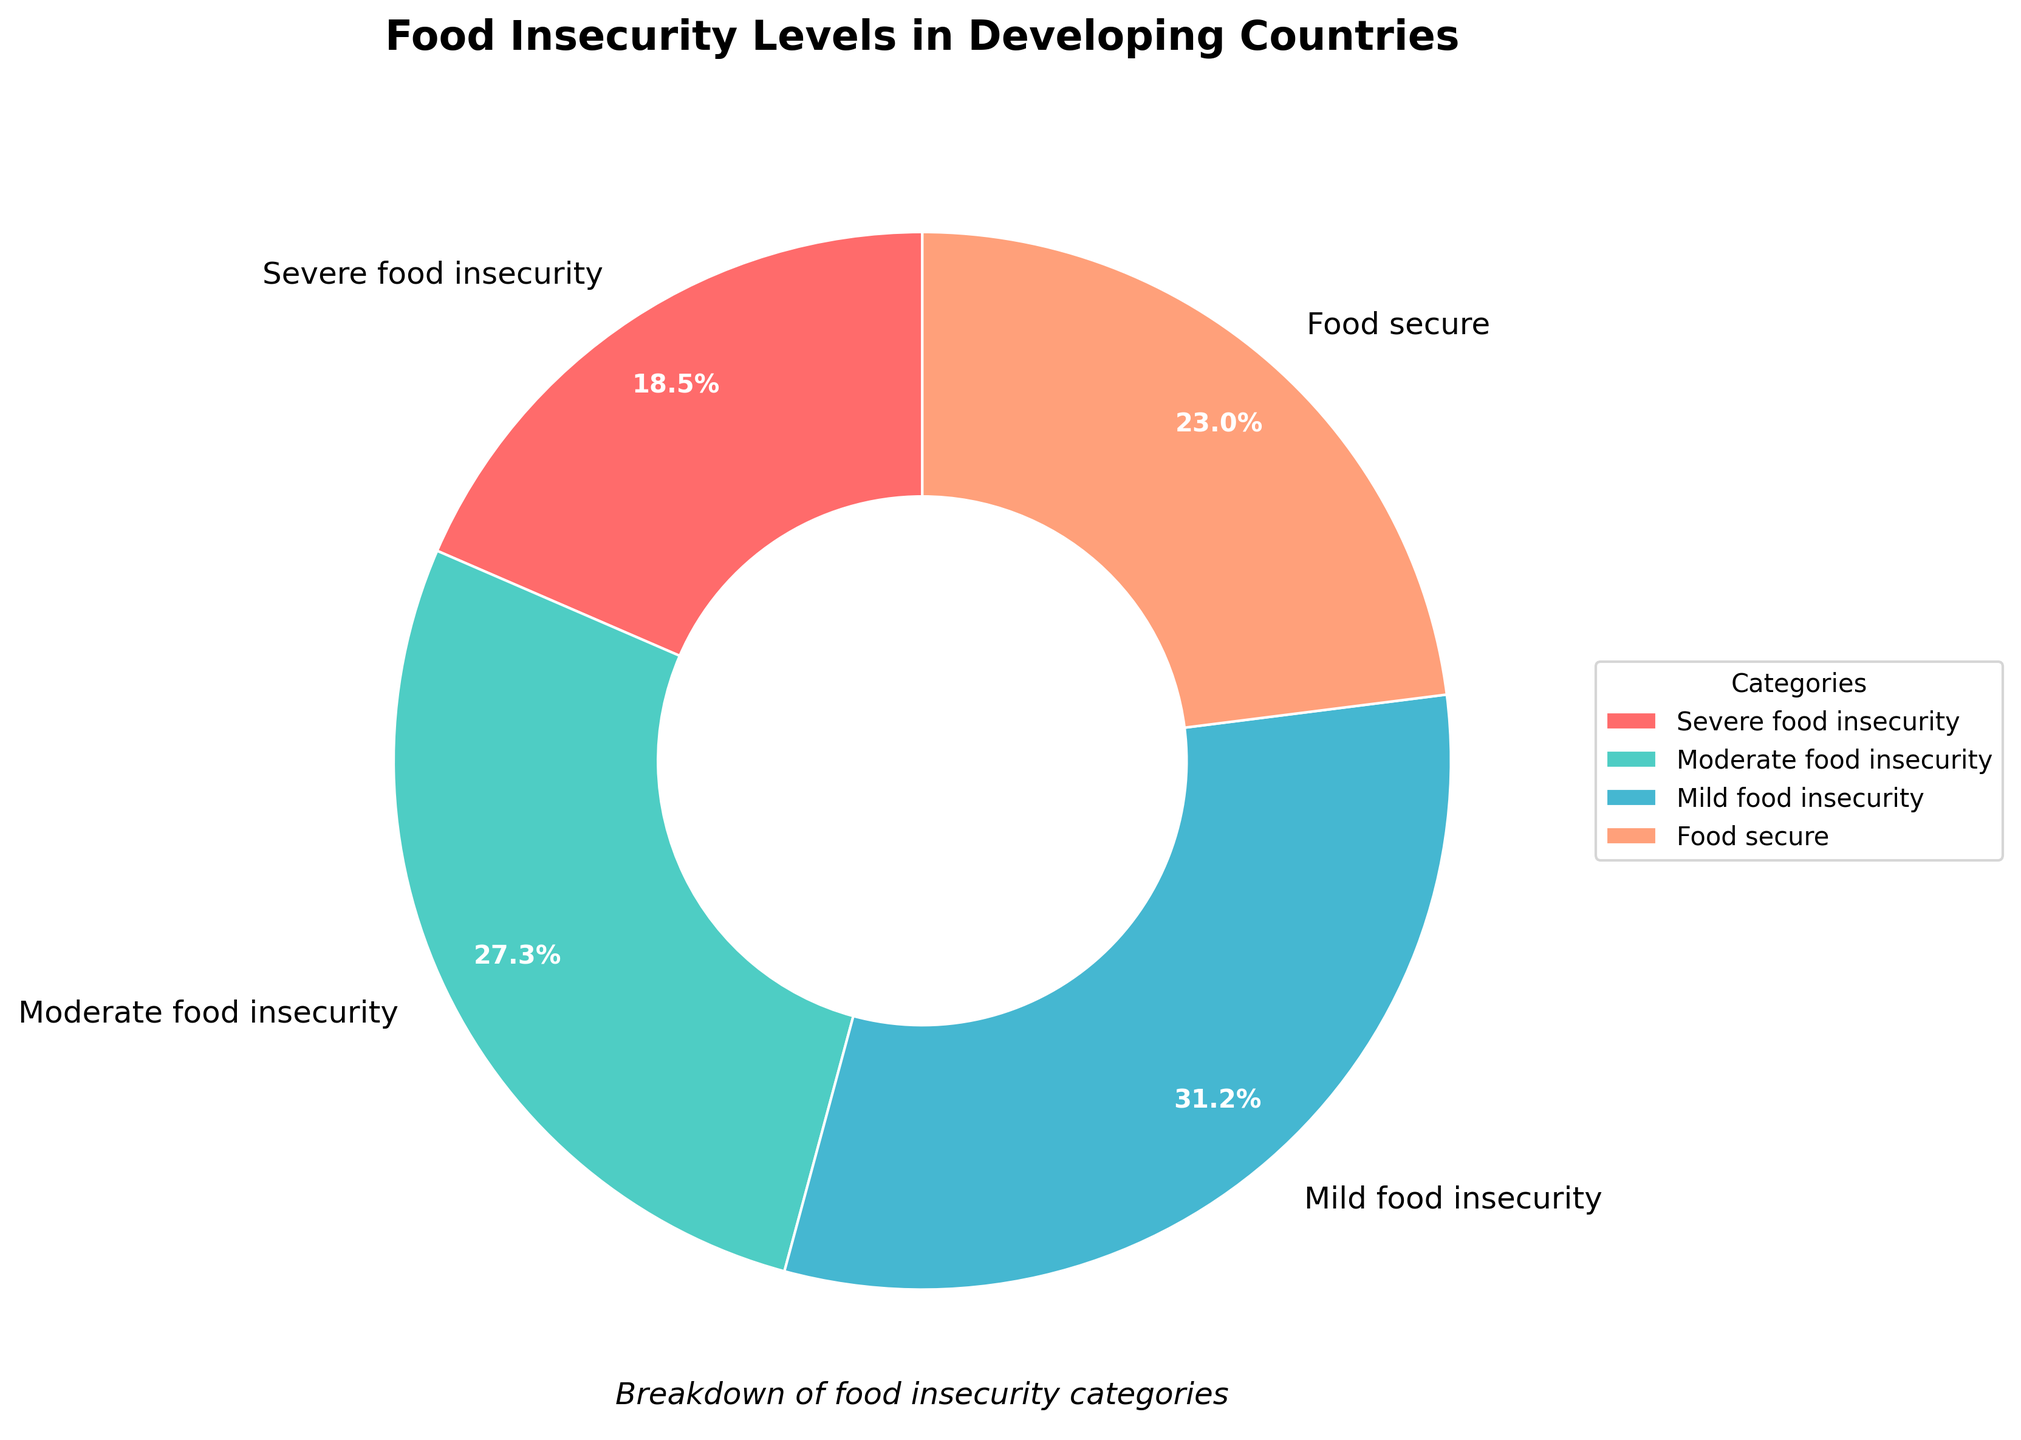What percentage of people are experiencing severe food insecurity? The chart reveals a segment labeled 'Severe food insecurity' with a percentage value indicated next to it. This percentage is 18.5%.
Answer: 18.5% Which food insecurity level has the highest percentage? Visual inspection of the pie chart shows four segments with their respective percentages. 'Mild food insecurity' has the largest segment with 31.2%.
Answer: Mild food insecurity How much greater is the percentage of people with mild food insecurity compared to those who are food secure? The percentage of people with mild food insecurity is 31.2%, and the percentage of food-secure individuals is 23.0%. Subtracting these values gives 31.2% - 23.0% = 8.2%.
Answer: 8.2% What is the total percentage of people experiencing either moderate or severe food insecurity? The chart shows the percentages for moderate food insecurity (27.3%) and severe food insecurity (18.5%). Adding these values together gives 27.3% + 18.5% = 45.8%.
Answer: 45.8% Compare the percentage of people who are food secure with those experiencing moderate food insecurity. Which is greater? The pie chart indicates the percentage of food-secure individuals as 23.0% and those with moderate food insecurity as 27.3%. Comparing these percentages, moderate food insecurity is greater.
Answer: Moderate food insecurity Of the four categories, which one has the smallest representation? The pie chart illustrates the smallest segment in terms of percentage size, which is the 'Severe food insecurity' category at 18.5%.
Answer: Severe food insecurity What is the difference in percentage between the highest and the lowest food insecurity levels? The highest percentage is 'Mild food insecurity' at 31.2%, and the lowest is 'Severe food insecurity' at 18.5%. Calculating the difference gives 31.2% - 18.5% = 12.7%.
Answer: 12.7% What is the average percentage of the four food insecurity levels provided? To find the average, sum the percentages of all four levels (18.5 + 27.3 + 31.2 + 23.0) and divide by 4. This results in (100% / 4) = 25%.
Answer: 25% 